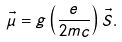<formula> <loc_0><loc_0><loc_500><loc_500>\vec { \mu } = g \left ( \frac { e } { 2 m c } \right ) \vec { S } .</formula> 